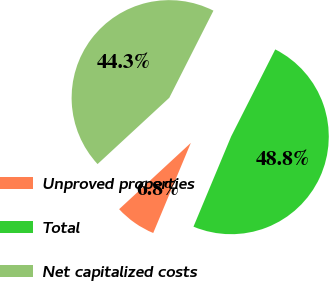Convert chart to OTSL. <chart><loc_0><loc_0><loc_500><loc_500><pie_chart><fcel>Unproved properties<fcel>Total<fcel>Net capitalized costs<nl><fcel>6.83%<fcel>48.83%<fcel>44.34%<nl></chart> 